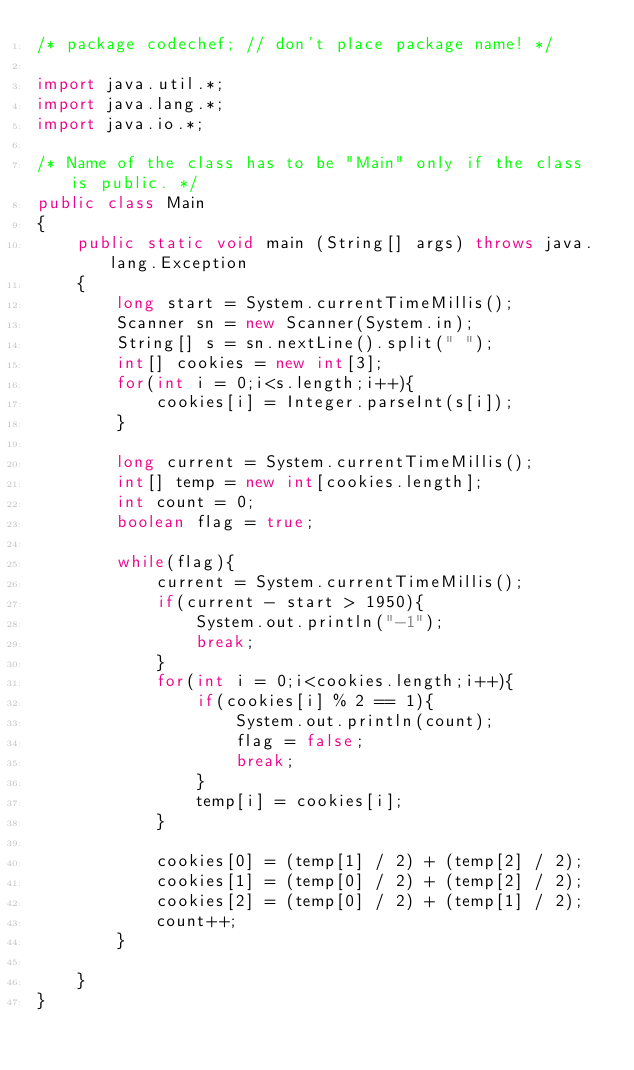Convert code to text. <code><loc_0><loc_0><loc_500><loc_500><_Java_>/* package codechef; // don't place package name! */

import java.util.*;
import java.lang.*;
import java.io.*;

/* Name of the class has to be "Main" only if the class is public. */
public class Main
{
	public static void main (String[] args) throws java.lang.Exception
	{
	    long start = System.currentTimeMillis();
	    Scanner sn = new Scanner(System.in);
	    String[] s = sn.nextLine().split(" ");
	    int[] cookies = new int[3];
	    for(int i = 0;i<s.length;i++){
	        cookies[i] = Integer.parseInt(s[i]);
	    }
	    
	    long current = System.currentTimeMillis();
	    int[] temp = new int[cookies.length];
	    int count = 0;
	    boolean flag = true;
	    
	    while(flag){
	        current = System.currentTimeMillis();
	        if(current - start > 1950){
	            System.out.println("-1");
	            break;
	        }
	        for(int i = 0;i<cookies.length;i++){
	            if(cookies[i] % 2 == 1){
	                System.out.println(count);
	                flag = false;
	                break;
	            }
	            temp[i] = cookies[i];
	        }
	        
	        cookies[0] = (temp[1] / 2) + (temp[2] / 2);
	        cookies[1] = (temp[0] / 2) + (temp[2] / 2);
	        cookies[2] = (temp[0] / 2) + (temp[1] / 2);
	        count++;
	    }
	    
	}
}
</code> 